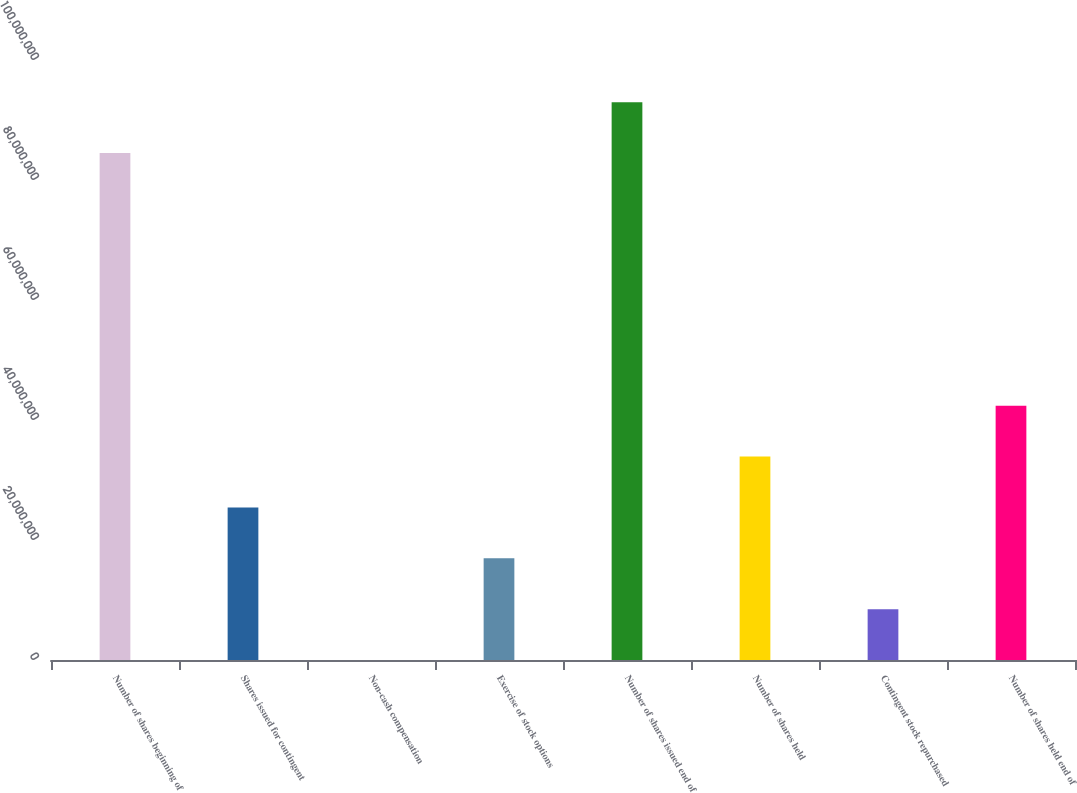Convert chart. <chart><loc_0><loc_0><loc_500><loc_500><bar_chart><fcel>Number of shares beginning of<fcel>Shares issued for contingent<fcel>Non-cash compensation<fcel>Exercise of stock options<fcel>Number of shares issued end of<fcel>Number of shares held<fcel>Contingent stock repurchased<fcel>Number of shares held end of<nl><fcel>8.44945e+07<fcel>2.54311e+07<fcel>2605<fcel>1.6955e+07<fcel>9.29707e+07<fcel>3.39073e+07<fcel>8.47878e+06<fcel>4.23835e+07<nl></chart> 